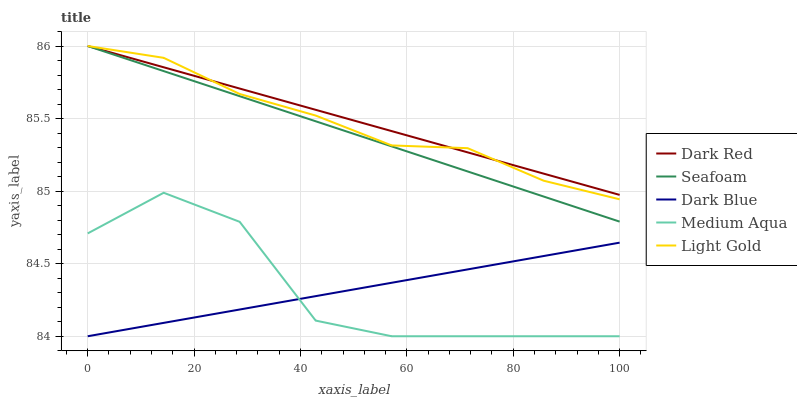Does Medium Aqua have the minimum area under the curve?
Answer yes or no. Yes. Does Dark Red have the maximum area under the curve?
Answer yes or no. Yes. Does Light Gold have the minimum area under the curve?
Answer yes or no. No. Does Light Gold have the maximum area under the curve?
Answer yes or no. No. Is Dark Blue the smoothest?
Answer yes or no. Yes. Is Medium Aqua the roughest?
Answer yes or no. Yes. Is Light Gold the smoothest?
Answer yes or no. No. Is Light Gold the roughest?
Answer yes or no. No. Does Medium Aqua have the lowest value?
Answer yes or no. Yes. Does Light Gold have the lowest value?
Answer yes or no. No. Does Seafoam have the highest value?
Answer yes or no. Yes. Does Medium Aqua have the highest value?
Answer yes or no. No. Is Dark Blue less than Light Gold?
Answer yes or no. Yes. Is Light Gold greater than Dark Blue?
Answer yes or no. Yes. Does Dark Red intersect Seafoam?
Answer yes or no. Yes. Is Dark Red less than Seafoam?
Answer yes or no. No. Is Dark Red greater than Seafoam?
Answer yes or no. No. Does Dark Blue intersect Light Gold?
Answer yes or no. No. 